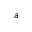<formula> <loc_0><loc_0><loc_500><loc_500>a</formula> 